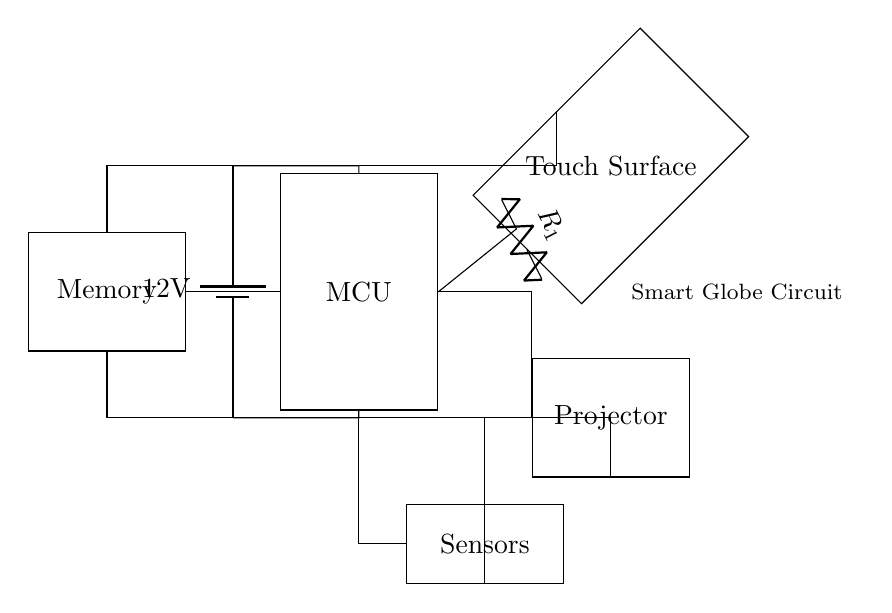What is the main component of this circuit? The main component is the microcontroller, which is essential for controlling the functions of the smart globe, processing input from the touch-sensitive surface and outputting signals to the projector.
Answer: Microcontroller What is the voltage supplied to the circuit? The voltage supplied is twelve volts, indicated by the battery symbol in the circuit diagram that is labeled with twelve volts.
Answer: Twelve volts How many external components are connected to the microcontroller? There are three external components connected to the microcontroller: the touch-sensitive surface, the projector, and the memory unit, all shown as separate rectangles connected to the microcontroller.
Answer: Three What type of sensors are shown in the circuit? The type of sensors is unspecified, but they are represented as a rectangle labeled "Sensors," connected to the microcontroller for gathering geographical data or touch interactions.
Answer: Sensors How does the power supply connect to the project? The power supply connects to the circuit through several paths, first going to the microcontroller, and also has direct connections to the touch-sensitive surface, projector, and memory, ensuring that all components receive the required voltage.
Answer: Through multiple paths What is the function of the memory component in the circuit? The memory component stores geographical information and data that can be accessed by the microcontroller, facilitating interaction with the touch-sensitive surface and display requirements of the projector.
Answer: Data storage 